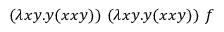<formula> <loc_0><loc_0><loc_500><loc_500>( \lambda x y . y ( x x y ) ) \ ( \lambda x y . y ( x x y ) ) \ f</formula> 